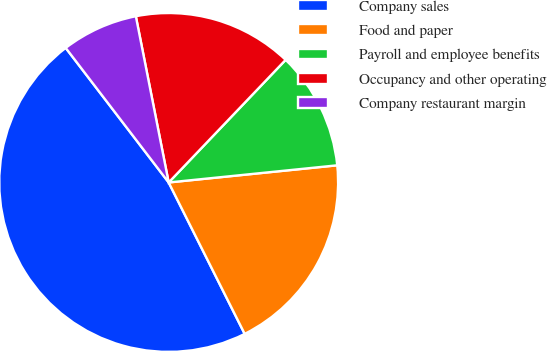Convert chart. <chart><loc_0><loc_0><loc_500><loc_500><pie_chart><fcel>Company sales<fcel>Food and paper<fcel>Payroll and employee benefits<fcel>Occupancy and other operating<fcel>Company restaurant margin<nl><fcel>47.01%<fcel>19.21%<fcel>11.26%<fcel>15.23%<fcel>7.29%<nl></chart> 